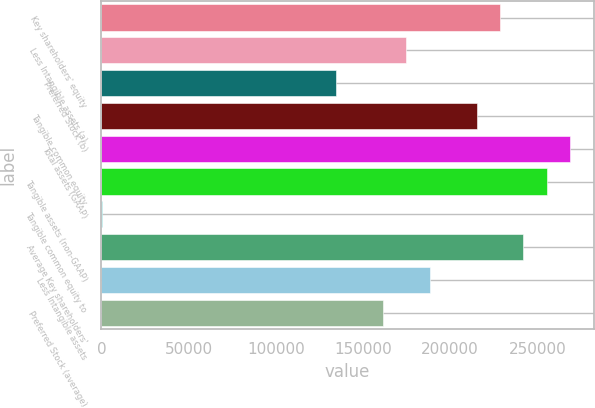<chart> <loc_0><loc_0><loc_500><loc_500><bar_chart><fcel>Key shareholders' equity<fcel>Less Intangible assets (a)<fcel>Preferred Stock (b)<fcel>Tangible common equity<fcel>Total assets (GAAP)<fcel>Tangible assets (non-GAAP)<fcel>Tangible common equity to<fcel>Average Key shareholders'<fcel>Less Intangible assets<fcel>Preferred Stock (average)<nl><fcel>228603<fcel>174816<fcel>134476<fcel>215157<fcel>268944<fcel>255497<fcel>8.51<fcel>242050<fcel>188263<fcel>161370<nl></chart> 